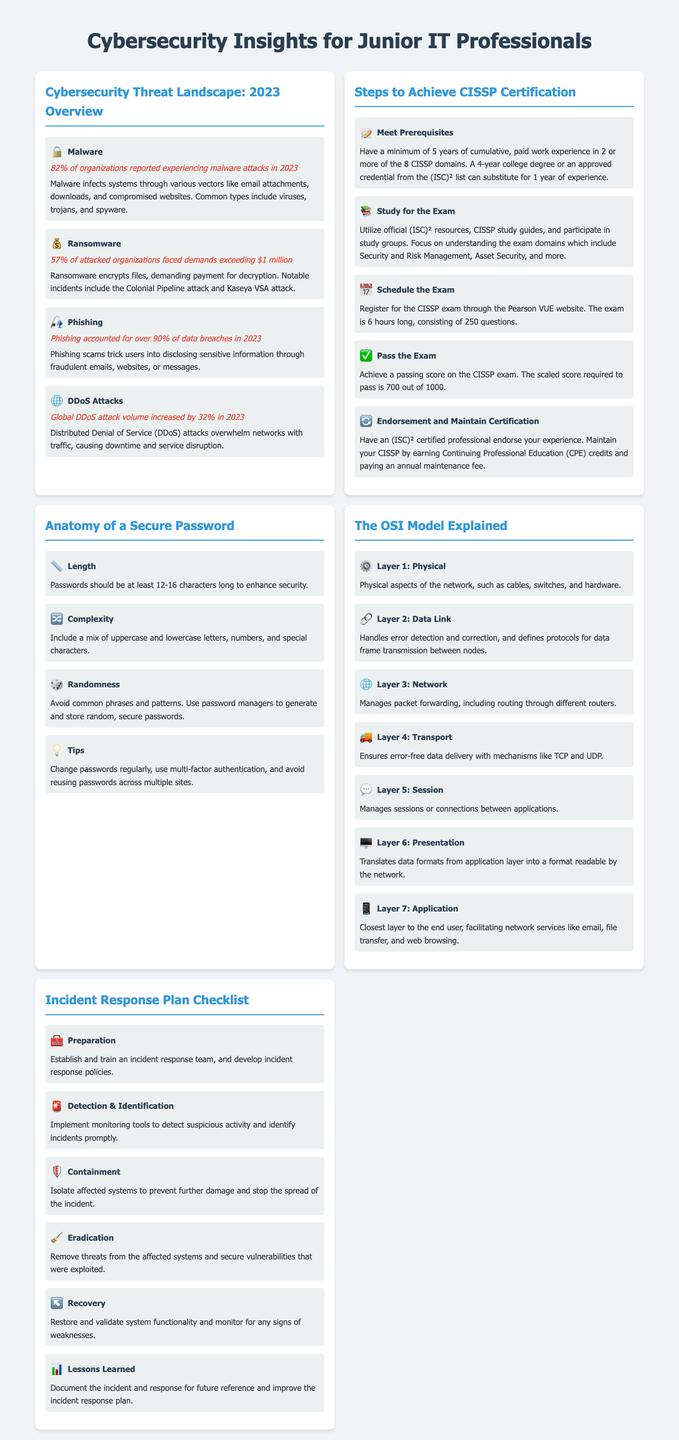What percentage of organizations reported experiencing malware attacks in 2023? The document states that 82% of organizations experienced malware attacks in 2023.
Answer: 82% What is a significant demand faced by attacked organizations in terms of ransomware? The infographic indicates that 57% of attacked organizations faced demands exceeding $1 million.
Answer: $1 million Which type of attack accounted for over 90% of data breaches in 2023? The document specifies that phishing accounted for over 90% of data breaches.
Answer: Phishing What is the required score to pass the CISSP exam? The document notes that the scaled score required to pass the CISSP exam is 700 out of 1000.
Answer: 700 How many years of experience are required to meet the prerequisites for CISSP certification? It states that a minimum of 5 years of cumulative, paid work experience is necessary.
Answer: 5 years What is the first step in an incident response plan checklist? The infographic outlines that the first step is preparation, which involves establishing a team and policies.
Answer: Preparation What layer of the OSI model handles packet forwarding? The document explains that Layer 3 of the OSI model manages packet forwarding.
Answer: Layer 3 What is the minimum recommended password length for security? The infographic suggests that passwords should be at least 12-16 characters long.
Answer: 12-16 characters What step follows detection and identification in the incident response plan? The document states that containment follows detection and identification in the response plan.
Answer: Containment 